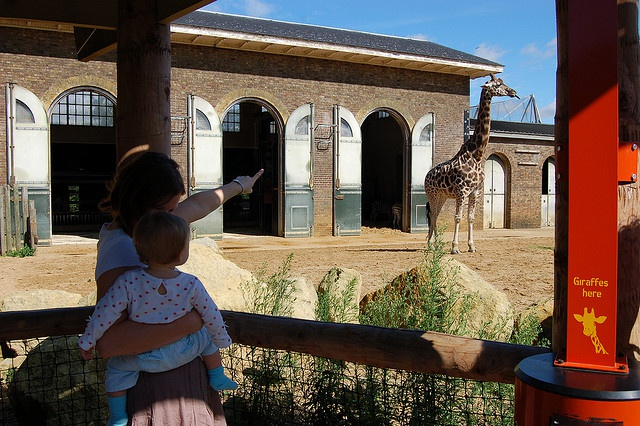Describe the objects in this image and their specific colors. I can see people in black, maroon, navy, and gray tones, people in black, gray, blue, and navy tones, and giraffe in black, maroon, and gray tones in this image. 